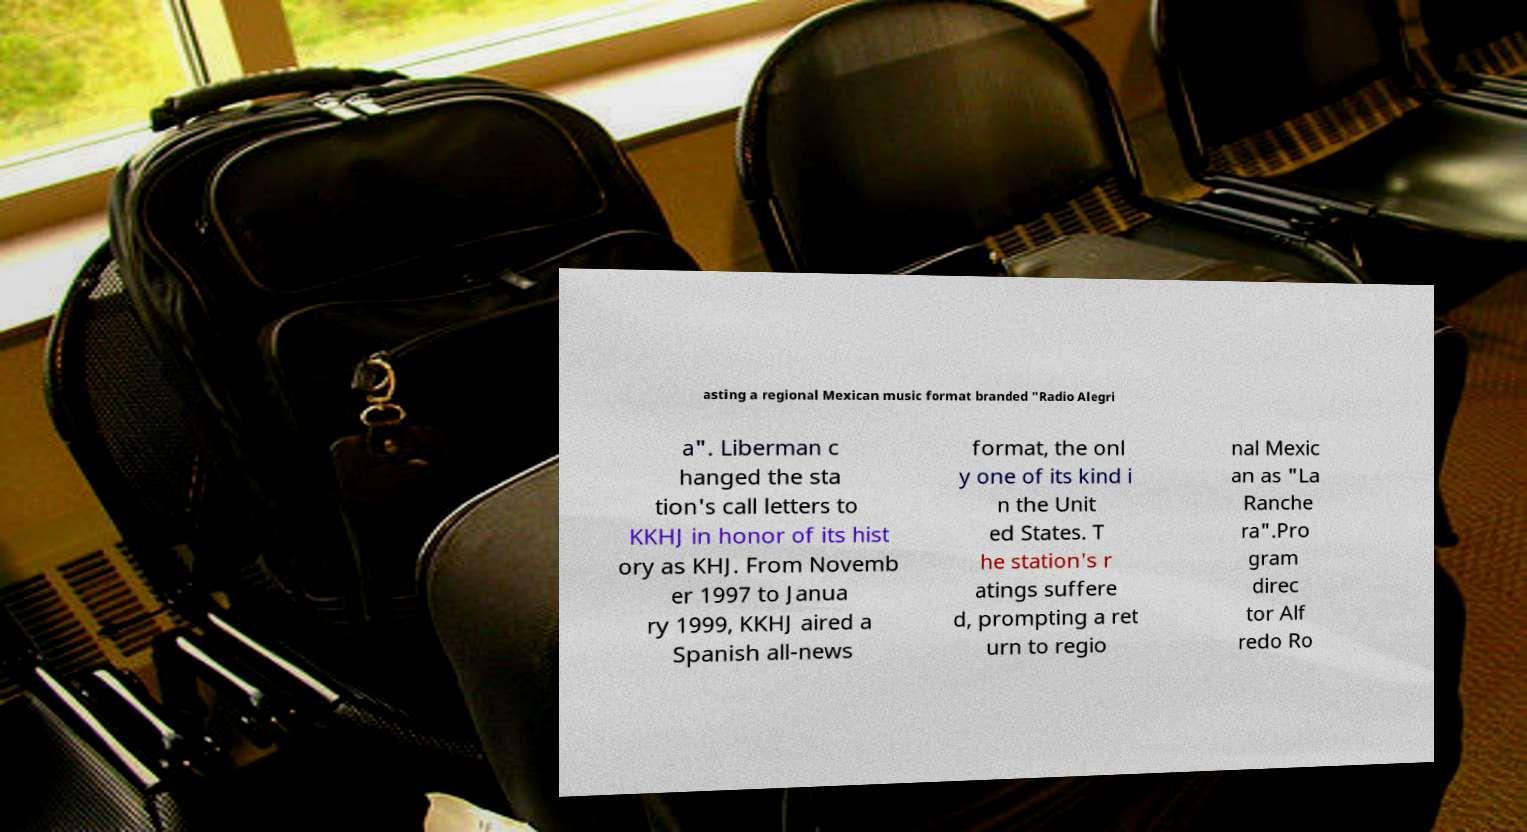For documentation purposes, I need the text within this image transcribed. Could you provide that? asting a regional Mexican music format branded "Radio Alegri a". Liberman c hanged the sta tion's call letters to KKHJ in honor of its hist ory as KHJ. From Novemb er 1997 to Janua ry 1999, KKHJ aired a Spanish all-news format, the onl y one of its kind i n the Unit ed States. T he station's r atings suffere d, prompting a ret urn to regio nal Mexic an as "La Ranche ra".Pro gram direc tor Alf redo Ro 